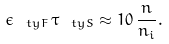Convert formula to latex. <formula><loc_0><loc_0><loc_500><loc_500>\epsilon _ { \ t y { F } } \, \tau _ { \ t y { S } } \approx 1 0 \, \frac { n } { n _ { i } } .</formula> 